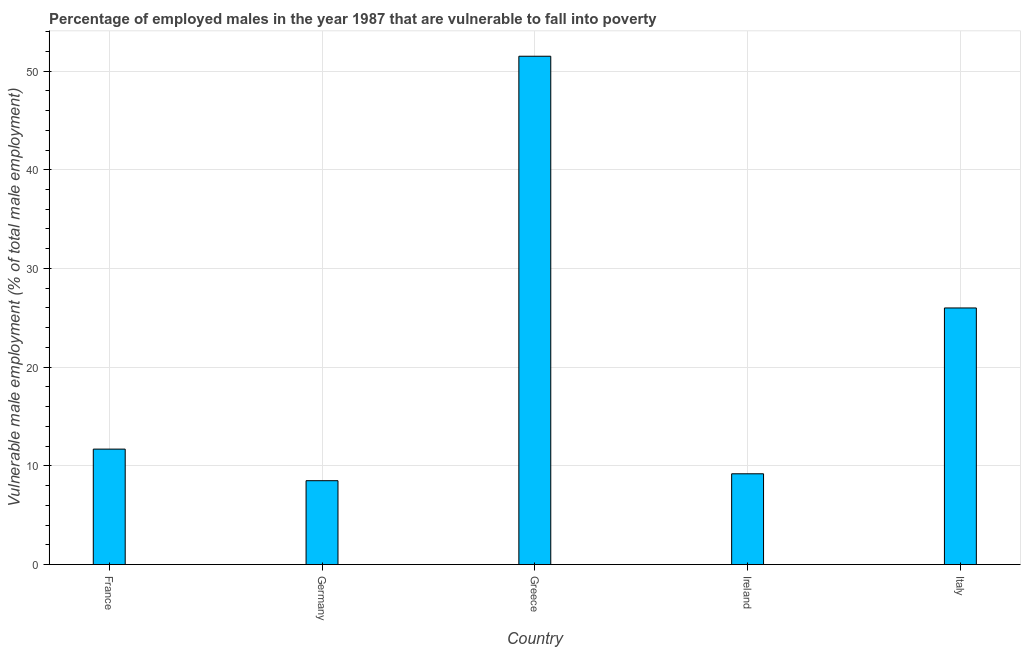Does the graph contain any zero values?
Provide a short and direct response. No. What is the title of the graph?
Your answer should be compact. Percentage of employed males in the year 1987 that are vulnerable to fall into poverty. What is the label or title of the Y-axis?
Provide a short and direct response. Vulnerable male employment (% of total male employment). What is the percentage of employed males who are vulnerable to fall into poverty in Ireland?
Offer a terse response. 9.2. Across all countries, what is the maximum percentage of employed males who are vulnerable to fall into poverty?
Provide a short and direct response. 51.5. In which country was the percentage of employed males who are vulnerable to fall into poverty maximum?
Your answer should be very brief. Greece. In which country was the percentage of employed males who are vulnerable to fall into poverty minimum?
Keep it short and to the point. Germany. What is the sum of the percentage of employed males who are vulnerable to fall into poverty?
Offer a terse response. 106.9. What is the difference between the percentage of employed males who are vulnerable to fall into poverty in France and Germany?
Ensure brevity in your answer.  3.2. What is the average percentage of employed males who are vulnerable to fall into poverty per country?
Your answer should be compact. 21.38. What is the median percentage of employed males who are vulnerable to fall into poverty?
Your answer should be very brief. 11.7. What is the ratio of the percentage of employed males who are vulnerable to fall into poverty in Greece to that in Italy?
Give a very brief answer. 1.98. Is the difference between the percentage of employed males who are vulnerable to fall into poverty in France and Ireland greater than the difference between any two countries?
Your response must be concise. No. Is the sum of the percentage of employed males who are vulnerable to fall into poverty in Greece and Ireland greater than the maximum percentage of employed males who are vulnerable to fall into poverty across all countries?
Provide a succinct answer. Yes. What is the difference between the highest and the lowest percentage of employed males who are vulnerable to fall into poverty?
Your answer should be very brief. 43. What is the difference between two consecutive major ticks on the Y-axis?
Give a very brief answer. 10. Are the values on the major ticks of Y-axis written in scientific E-notation?
Offer a terse response. No. What is the Vulnerable male employment (% of total male employment) of France?
Ensure brevity in your answer.  11.7. What is the Vulnerable male employment (% of total male employment) of Germany?
Your answer should be very brief. 8.5. What is the Vulnerable male employment (% of total male employment) in Greece?
Your answer should be very brief. 51.5. What is the Vulnerable male employment (% of total male employment) in Ireland?
Keep it short and to the point. 9.2. What is the Vulnerable male employment (% of total male employment) in Italy?
Provide a short and direct response. 26. What is the difference between the Vulnerable male employment (% of total male employment) in France and Greece?
Offer a very short reply. -39.8. What is the difference between the Vulnerable male employment (% of total male employment) in France and Ireland?
Offer a terse response. 2.5. What is the difference between the Vulnerable male employment (% of total male employment) in France and Italy?
Keep it short and to the point. -14.3. What is the difference between the Vulnerable male employment (% of total male employment) in Germany and Greece?
Offer a very short reply. -43. What is the difference between the Vulnerable male employment (% of total male employment) in Germany and Italy?
Provide a succinct answer. -17.5. What is the difference between the Vulnerable male employment (% of total male employment) in Greece and Ireland?
Give a very brief answer. 42.3. What is the difference between the Vulnerable male employment (% of total male employment) in Ireland and Italy?
Your response must be concise. -16.8. What is the ratio of the Vulnerable male employment (% of total male employment) in France to that in Germany?
Provide a short and direct response. 1.38. What is the ratio of the Vulnerable male employment (% of total male employment) in France to that in Greece?
Your response must be concise. 0.23. What is the ratio of the Vulnerable male employment (% of total male employment) in France to that in Ireland?
Your response must be concise. 1.27. What is the ratio of the Vulnerable male employment (% of total male employment) in France to that in Italy?
Your answer should be compact. 0.45. What is the ratio of the Vulnerable male employment (% of total male employment) in Germany to that in Greece?
Offer a terse response. 0.17. What is the ratio of the Vulnerable male employment (% of total male employment) in Germany to that in Ireland?
Give a very brief answer. 0.92. What is the ratio of the Vulnerable male employment (% of total male employment) in Germany to that in Italy?
Keep it short and to the point. 0.33. What is the ratio of the Vulnerable male employment (% of total male employment) in Greece to that in Ireland?
Make the answer very short. 5.6. What is the ratio of the Vulnerable male employment (% of total male employment) in Greece to that in Italy?
Offer a very short reply. 1.98. What is the ratio of the Vulnerable male employment (% of total male employment) in Ireland to that in Italy?
Your response must be concise. 0.35. 